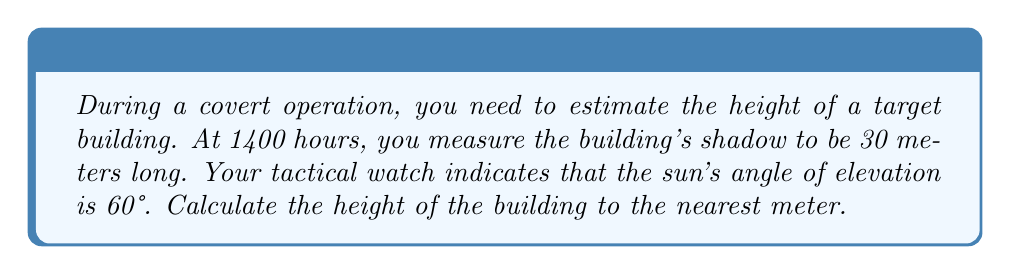Show me your answer to this math problem. Let's approach this step-by-step using trigonometry:

1) We can model this situation as a right triangle, where:
   - The building's height is the opposite side
   - The shadow's length is the adjacent side
   - The sun's rays form the hypotenuse

2) We know:
   - The angle of elevation (θ) = 60°
   - The length of the shadow (adjacent) = 30 meters

3) We need to find the height of the building (opposite side). The tangent function relates the opposite and adjacent sides:

   $$\tan θ = \frac{\text{opposite}}{\text{adjacent}}$$

4) Rearranging this equation:

   $$\text{opposite} = \text{adjacent} \times \tan θ$$

5) Substituting our known values:

   $$\text{height} = 30 \times \tan 60°$$

6) We know that $\tan 60° = \sqrt{3}$, so:

   $$\text{height} = 30 \times \sqrt{3}$$

7) Calculate:
   $$\text{height} = 30 \times 1.732 ≈ 51.96 \text{ meters}$$

8) Rounding to the nearest meter:

   $$\text{height} ≈ 52 \text{ meters}$$
Answer: 52 meters 